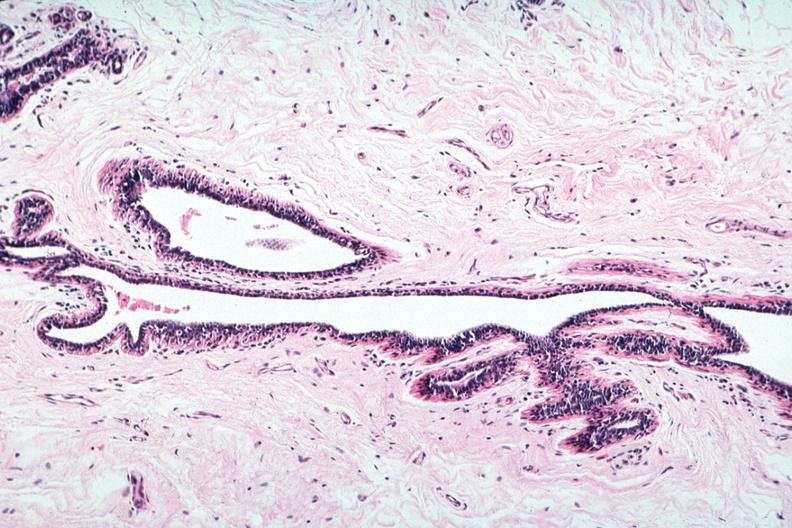does side show normal duct in postmenopausal woman?
Answer the question using a single word or phrase. No 